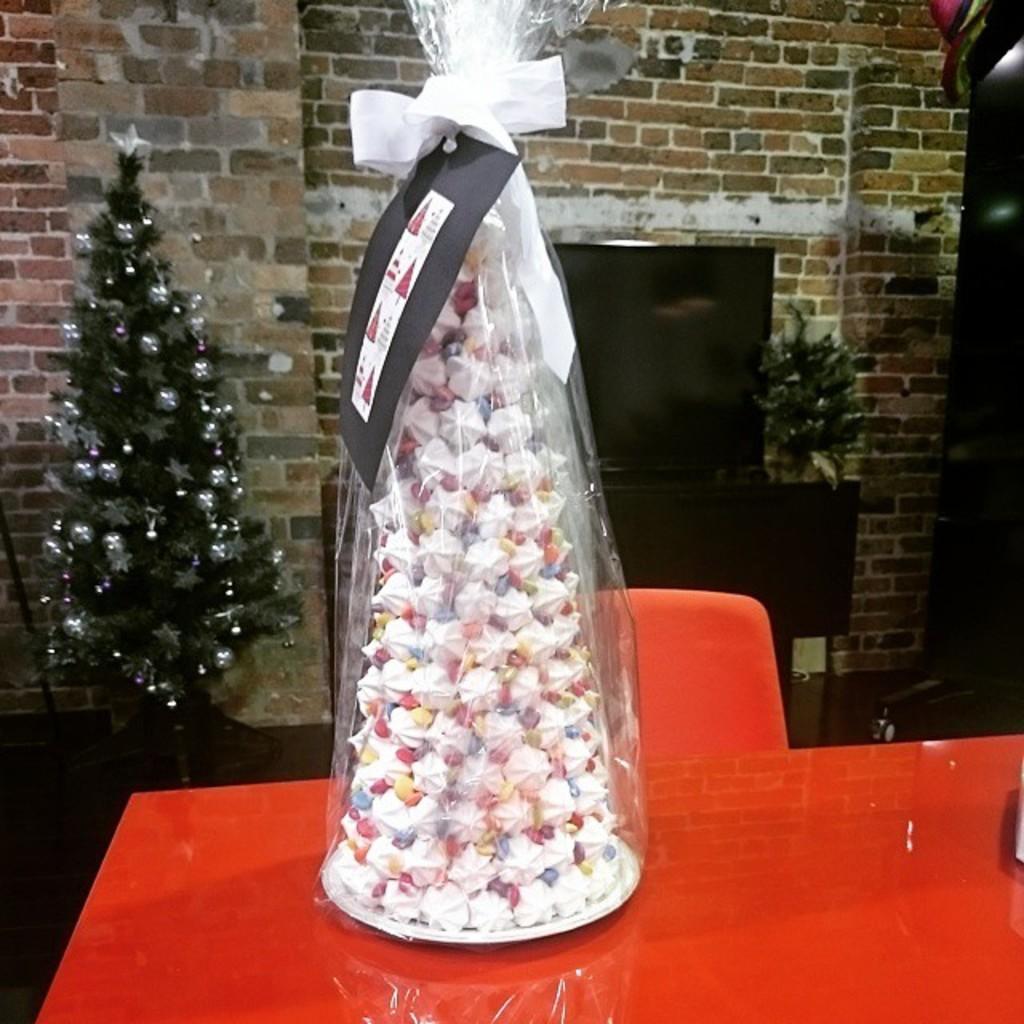Please provide a concise description of this image. In this image there is a cone shaped cake wrapped with a cover and ribbons, which is on the table, and in the background there is a chair, plant, television on the cupboard, artificial tree decorated with balls and stars. 